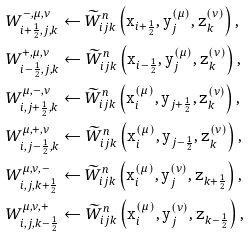Convert formula to latex. <formula><loc_0><loc_0><loc_500><loc_500>& { W } ^ { - , \mu , \nu } _ { i + \frac { 1 } { 2 } , j , k } \leftarrow \widetilde { W } _ { i j k } ^ { n } \left ( { \tt x } _ { i + \frac { 1 } { 2 } } , { \tt y } _ { j } ^ { ( \mu ) } , { \tt z } _ { k } ^ { ( \nu ) } \right ) , \\ & { W } ^ { + , \mu , \nu } _ { i - \frac { 1 } { 2 } , j , k } \leftarrow \widetilde { W } _ { i j k } ^ { n } \left ( { \tt x } _ { i - \frac { 1 } { 2 } } , { \tt y } _ { j } ^ { ( \mu ) } , { \tt z } _ { k } ^ { ( \nu ) } \right ) , \\ & { W } ^ { \mu , - , \nu } _ { i , j + \frac { 1 } { 2 } , k } \leftarrow \widetilde { W } _ { i j k } ^ { n } \left ( { \tt x } _ { i } ^ { ( \mu ) } , { \tt y } _ { j + \frac { 1 } { 2 } } , { \tt z } _ { k } ^ { ( \nu ) } \right ) , \\ & { W } ^ { \mu , + , \nu } _ { i , j - \frac { 1 } { 2 } , k } \leftarrow \widetilde { W } _ { i j k } ^ { n } \left ( { \tt x } _ { i } ^ { ( \mu ) } , { \tt y } _ { j - \frac { 1 } { 2 } } , { \tt z } _ { k } ^ { ( \nu ) } \right ) , \\ & { W } ^ { \mu , \nu , - } _ { i , j , k + \frac { 1 } { 2 } } \leftarrow \widetilde { W } _ { i j k } ^ { n } \left ( { \tt x } _ { i } ^ { ( \mu ) } , { \tt y } _ { j } ^ { ( \nu ) } , { \tt z } _ { k + \frac { 1 } { 2 } } \right ) , \\ & { W } ^ { \mu , \nu , + } _ { i , j , k - \frac { 1 } { 2 } } \leftarrow \widetilde { W } _ { i j k } ^ { n } \left ( { \tt x } _ { i } ^ { ( \mu ) } , { \tt y } _ { j } ^ { ( \nu ) } , { \tt z } _ { k - \frac { 1 } { 2 } } \right ) ,</formula> 